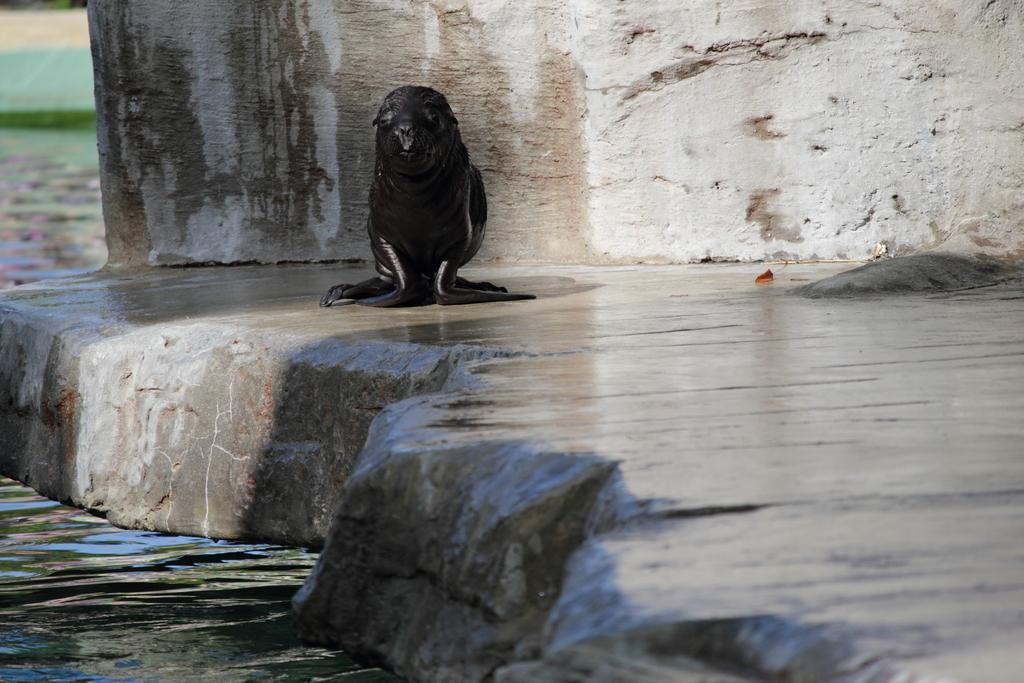What animal is on the surface in the image? There is a sea lion on the surface in the image. What can be seen in the background of the image? There is a wall and water visible in the background of the image. What is at the bottom of the image? There is water and a floor at the bottom of the image. What type of orange is being used as a wrench by the pigs in the image? There are no oranges, wrenches, or pigs present in the image. 